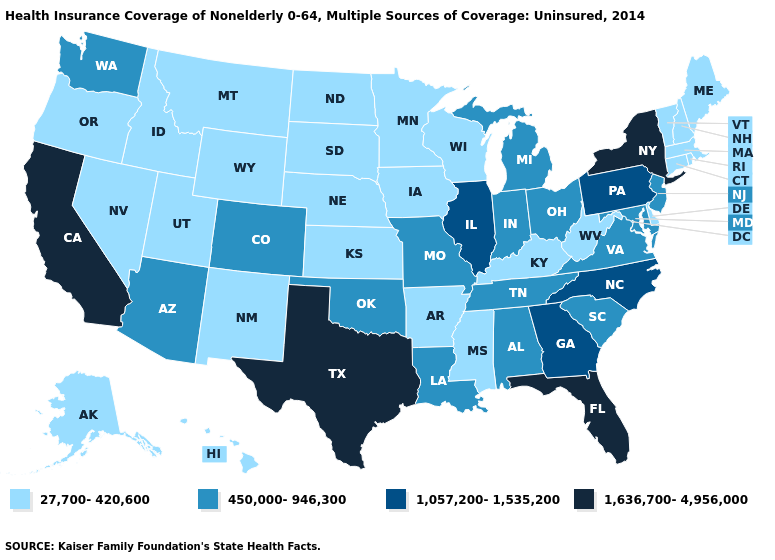Name the states that have a value in the range 1,636,700-4,956,000?
Give a very brief answer. California, Florida, New York, Texas. What is the highest value in the USA?
Answer briefly. 1,636,700-4,956,000. Does Alaska have a lower value than Alabama?
Write a very short answer. Yes. Name the states that have a value in the range 1,057,200-1,535,200?
Write a very short answer. Georgia, Illinois, North Carolina, Pennsylvania. Among the states that border Idaho , does Washington have the lowest value?
Short answer required. No. Name the states that have a value in the range 1,057,200-1,535,200?
Write a very short answer. Georgia, Illinois, North Carolina, Pennsylvania. Name the states that have a value in the range 1,636,700-4,956,000?
Concise answer only. California, Florida, New York, Texas. Does Kentucky have the lowest value in the South?
Write a very short answer. Yes. Among the states that border Wisconsin , which have the lowest value?
Be succinct. Iowa, Minnesota. Does Idaho have the same value as Massachusetts?
Answer briefly. Yes. Name the states that have a value in the range 1,636,700-4,956,000?
Be succinct. California, Florida, New York, Texas. Which states have the highest value in the USA?
Quick response, please. California, Florida, New York, Texas. Does the map have missing data?
Answer briefly. No. What is the lowest value in states that border Wisconsin?
Keep it brief. 27,700-420,600. Which states have the lowest value in the USA?
Give a very brief answer. Alaska, Arkansas, Connecticut, Delaware, Hawaii, Idaho, Iowa, Kansas, Kentucky, Maine, Massachusetts, Minnesota, Mississippi, Montana, Nebraska, Nevada, New Hampshire, New Mexico, North Dakota, Oregon, Rhode Island, South Dakota, Utah, Vermont, West Virginia, Wisconsin, Wyoming. 